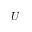Convert formula to latex. <formula><loc_0><loc_0><loc_500><loc_500>U</formula> 